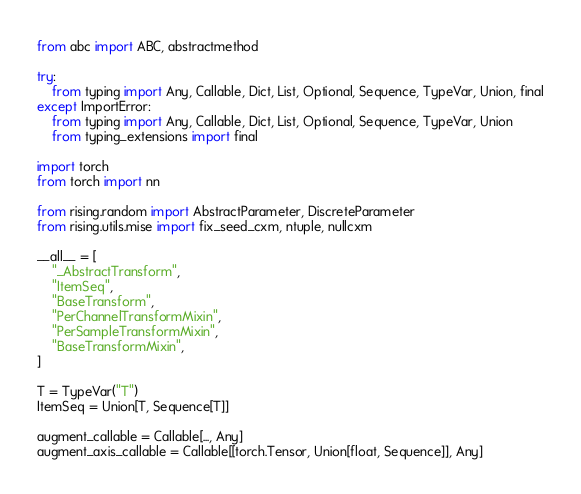<code> <loc_0><loc_0><loc_500><loc_500><_Python_>from abc import ABC, abstractmethod

try:
    from typing import Any, Callable, Dict, List, Optional, Sequence, TypeVar, Union, final
except ImportError:
    from typing import Any, Callable, Dict, List, Optional, Sequence, TypeVar, Union
    from typing_extensions import final

import torch
from torch import nn

from rising.random import AbstractParameter, DiscreteParameter
from rising.utils.mise import fix_seed_cxm, ntuple, nullcxm

__all__ = [
    "_AbstractTransform",
    "ItemSeq",
    "BaseTransform",
    "PerChannelTransformMixin",
    "PerSampleTransformMixin",
    "BaseTransformMixin",
]

T = TypeVar("T")
ItemSeq = Union[T, Sequence[T]]

augment_callable = Callable[..., Any]
augment_axis_callable = Callable[[torch.Tensor, Union[float, Sequence]], Any]

</code> 